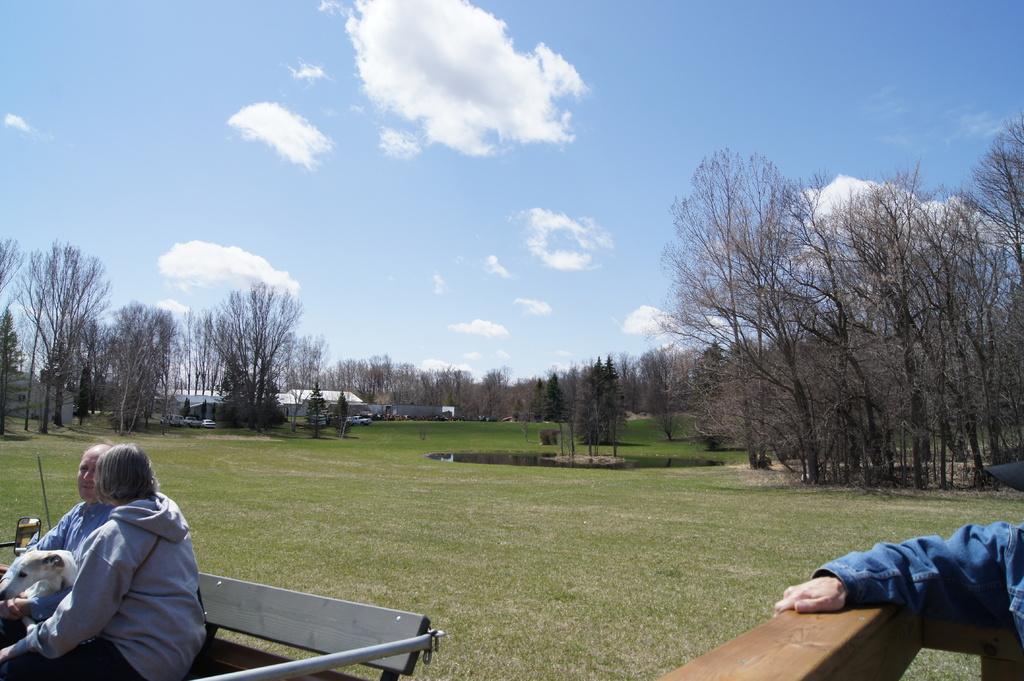Can you describe this image briefly? Here in the left bottom we can see two persons were sitting on the bench. On the right bottom we can see the human hand. And in the center we can see the grass some trees and sky with clouds. 